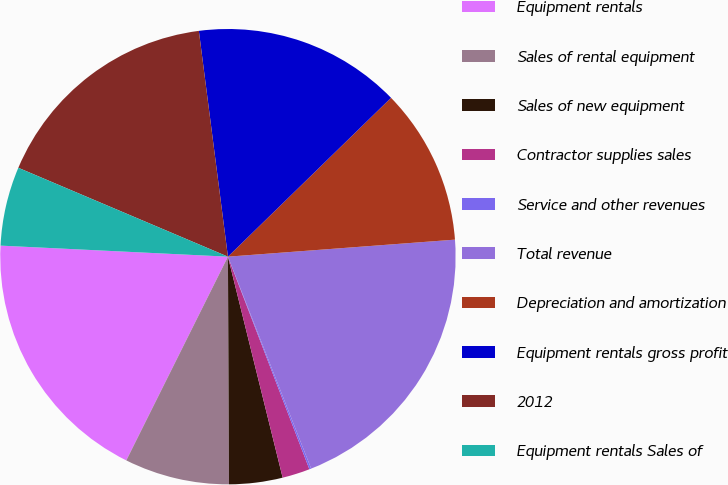Convert chart to OTSL. <chart><loc_0><loc_0><loc_500><loc_500><pie_chart><fcel>Equipment rentals<fcel>Sales of rental equipment<fcel>Sales of new equipment<fcel>Contractor supplies sales<fcel>Service and other revenues<fcel>Total revenue<fcel>Depreciation and amortization<fcel>Equipment rentals gross profit<fcel>2012<fcel>Equipment rentals Sales of<nl><fcel>18.41%<fcel>7.44%<fcel>3.79%<fcel>1.96%<fcel>0.13%<fcel>20.24%<fcel>11.1%<fcel>14.75%<fcel>16.58%<fcel>5.61%<nl></chart> 